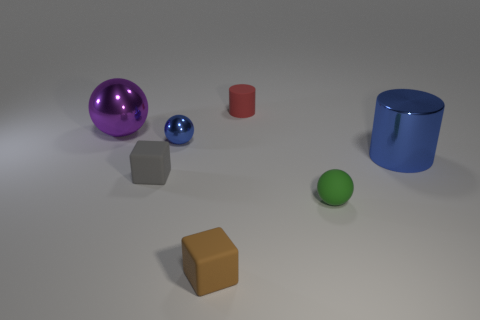There is a tiny ball that is behind the large thing on the right side of the green rubber object; what color is it?
Provide a short and direct response. Blue. There is a tiny matte cylinder; is its color the same as the matte thing that is in front of the small green ball?
Make the answer very short. No. There is a thing that is to the right of the small gray cube and left of the brown matte object; what is it made of?
Your answer should be compact. Metal. Is there a metal cylinder of the same size as the matte ball?
Make the answer very short. No. There is a green ball that is the same size as the gray cube; what is it made of?
Your answer should be very brief. Rubber. What number of tiny gray matte cubes are behind the gray rubber thing?
Offer a very short reply. 0. Is the shape of the large blue thing on the right side of the tiny red cylinder the same as  the small blue metal object?
Give a very brief answer. No. Is there a large blue object that has the same shape as the small red rubber thing?
Make the answer very short. Yes. There is another thing that is the same color as the small metal object; what material is it?
Offer a terse response. Metal. The small matte object left of the tiny brown thing in front of the large blue metallic thing is what shape?
Your answer should be compact. Cube. 